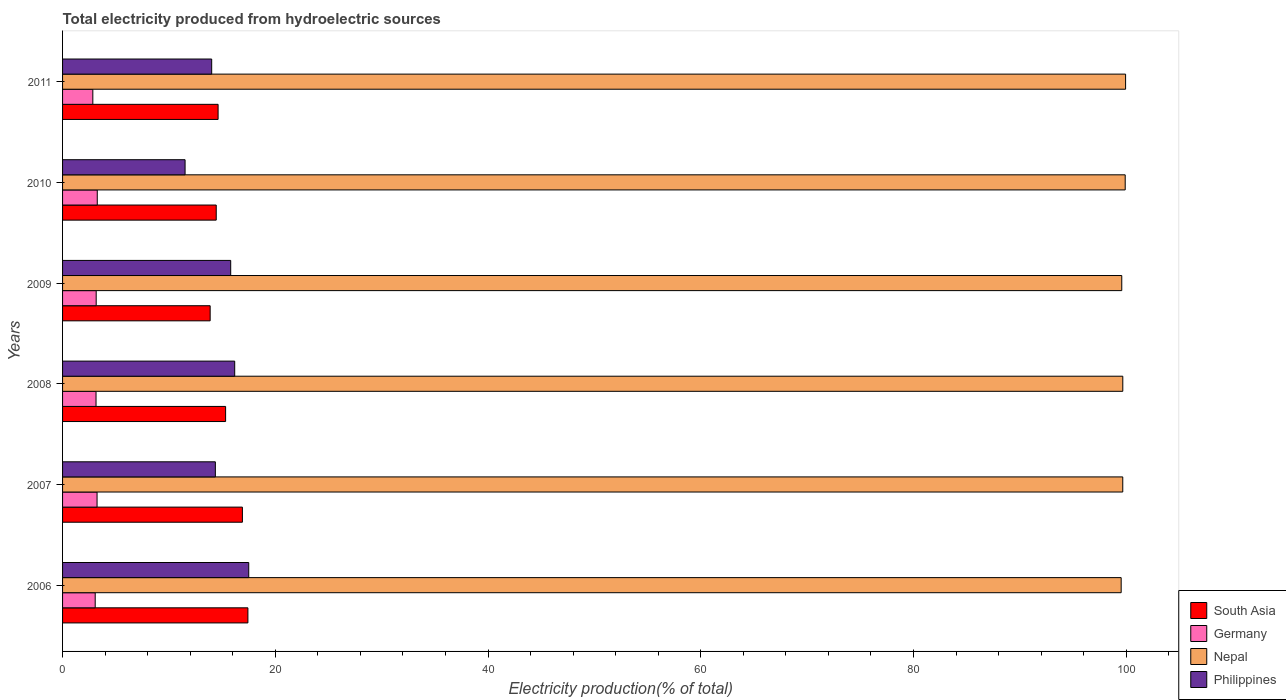Are the number of bars per tick equal to the number of legend labels?
Provide a succinct answer. Yes. What is the label of the 5th group of bars from the top?
Keep it short and to the point. 2007. In how many cases, is the number of bars for a given year not equal to the number of legend labels?
Give a very brief answer. 0. What is the total electricity produced in South Asia in 2006?
Ensure brevity in your answer.  17.43. Across all years, what is the maximum total electricity produced in Germany?
Provide a succinct answer. 3.26. Across all years, what is the minimum total electricity produced in Nepal?
Offer a terse response. 99.53. In which year was the total electricity produced in South Asia maximum?
Ensure brevity in your answer.  2006. In which year was the total electricity produced in South Asia minimum?
Provide a succinct answer. 2009. What is the total total electricity produced in South Asia in the graph?
Ensure brevity in your answer.  92.61. What is the difference between the total electricity produced in Nepal in 2007 and that in 2011?
Offer a terse response. -0.27. What is the difference between the total electricity produced in South Asia in 2011 and the total electricity produced in Nepal in 2007?
Keep it short and to the point. -85.05. What is the average total electricity produced in Germany per year?
Your response must be concise. 3.12. In the year 2006, what is the difference between the total electricity produced in Nepal and total electricity produced in South Asia?
Your answer should be very brief. 82.1. What is the ratio of the total electricity produced in Philippines in 2008 to that in 2011?
Keep it short and to the point. 1.15. Is the total electricity produced in Philippines in 2006 less than that in 2008?
Ensure brevity in your answer.  No. Is the difference between the total electricity produced in Nepal in 2006 and 2010 greater than the difference between the total electricity produced in South Asia in 2006 and 2010?
Your answer should be very brief. No. What is the difference between the highest and the second highest total electricity produced in Philippines?
Offer a very short reply. 1.32. What is the difference between the highest and the lowest total electricity produced in South Asia?
Your answer should be compact. 3.55. In how many years, is the total electricity produced in South Asia greater than the average total electricity produced in South Asia taken over all years?
Offer a terse response. 2. Is the sum of the total electricity produced in Philippines in 2006 and 2008 greater than the maximum total electricity produced in Nepal across all years?
Make the answer very short. No. What does the 3rd bar from the top in 2008 represents?
Make the answer very short. Germany. What does the 1st bar from the bottom in 2010 represents?
Make the answer very short. South Asia. How many bars are there?
Your response must be concise. 24. How many years are there in the graph?
Provide a succinct answer. 6. Does the graph contain any zero values?
Offer a terse response. No. Does the graph contain grids?
Your answer should be compact. No. How many legend labels are there?
Your answer should be compact. 4. How are the legend labels stacked?
Keep it short and to the point. Vertical. What is the title of the graph?
Provide a short and direct response. Total electricity produced from hydroelectric sources. What is the Electricity production(% of total) in South Asia in 2006?
Give a very brief answer. 17.43. What is the Electricity production(% of total) of Germany in 2006?
Offer a very short reply. 3.07. What is the Electricity production(% of total) of Nepal in 2006?
Give a very brief answer. 99.53. What is the Electricity production(% of total) of Philippines in 2006?
Give a very brief answer. 17.5. What is the Electricity production(% of total) in South Asia in 2007?
Offer a very short reply. 16.91. What is the Electricity production(% of total) of Germany in 2007?
Provide a short and direct response. 3.24. What is the Electricity production(% of total) in Nepal in 2007?
Provide a short and direct response. 99.68. What is the Electricity production(% of total) in Philippines in 2007?
Offer a terse response. 14.36. What is the Electricity production(% of total) of South Asia in 2008?
Offer a terse response. 15.33. What is the Electricity production(% of total) in Germany in 2008?
Your answer should be very brief. 3.15. What is the Electricity production(% of total) in Nepal in 2008?
Your answer should be compact. 99.68. What is the Electricity production(% of total) in Philippines in 2008?
Provide a short and direct response. 16.18. What is the Electricity production(% of total) in South Asia in 2009?
Give a very brief answer. 13.88. What is the Electricity production(% of total) in Germany in 2009?
Ensure brevity in your answer.  3.16. What is the Electricity production(% of total) of Nepal in 2009?
Give a very brief answer. 99.58. What is the Electricity production(% of total) in Philippines in 2009?
Offer a terse response. 15.81. What is the Electricity production(% of total) in South Asia in 2010?
Give a very brief answer. 14.45. What is the Electricity production(% of total) in Germany in 2010?
Make the answer very short. 3.26. What is the Electricity production(% of total) in Nepal in 2010?
Provide a short and direct response. 99.91. What is the Electricity production(% of total) of Philippines in 2010?
Your response must be concise. 11.52. What is the Electricity production(% of total) in South Asia in 2011?
Ensure brevity in your answer.  14.62. What is the Electricity production(% of total) of Germany in 2011?
Your answer should be compact. 2.85. What is the Electricity production(% of total) in Nepal in 2011?
Offer a very short reply. 99.94. What is the Electricity production(% of total) of Philippines in 2011?
Your answer should be very brief. 14.02. Across all years, what is the maximum Electricity production(% of total) of South Asia?
Your answer should be very brief. 17.43. Across all years, what is the maximum Electricity production(% of total) of Germany?
Provide a short and direct response. 3.26. Across all years, what is the maximum Electricity production(% of total) in Nepal?
Make the answer very short. 99.94. Across all years, what is the maximum Electricity production(% of total) in Philippines?
Offer a very short reply. 17.5. Across all years, what is the minimum Electricity production(% of total) in South Asia?
Provide a short and direct response. 13.88. Across all years, what is the minimum Electricity production(% of total) of Germany?
Ensure brevity in your answer.  2.85. Across all years, what is the minimum Electricity production(% of total) in Nepal?
Provide a succinct answer. 99.53. Across all years, what is the minimum Electricity production(% of total) in Philippines?
Ensure brevity in your answer.  11.52. What is the total Electricity production(% of total) in South Asia in the graph?
Your response must be concise. 92.61. What is the total Electricity production(% of total) of Germany in the graph?
Offer a terse response. 18.73. What is the total Electricity production(% of total) in Nepal in the graph?
Your answer should be compact. 598.32. What is the total Electricity production(% of total) in Philippines in the graph?
Keep it short and to the point. 89.4. What is the difference between the Electricity production(% of total) of South Asia in 2006 and that in 2007?
Provide a succinct answer. 0.52. What is the difference between the Electricity production(% of total) of Germany in 2006 and that in 2007?
Ensure brevity in your answer.  -0.17. What is the difference between the Electricity production(% of total) of Nepal in 2006 and that in 2007?
Your answer should be very brief. -0.15. What is the difference between the Electricity production(% of total) of Philippines in 2006 and that in 2007?
Offer a terse response. 3.14. What is the difference between the Electricity production(% of total) in South Asia in 2006 and that in 2008?
Offer a terse response. 2.1. What is the difference between the Electricity production(% of total) of Germany in 2006 and that in 2008?
Your response must be concise. -0.08. What is the difference between the Electricity production(% of total) of Nepal in 2006 and that in 2008?
Give a very brief answer. -0.15. What is the difference between the Electricity production(% of total) in Philippines in 2006 and that in 2008?
Your answer should be very brief. 1.32. What is the difference between the Electricity production(% of total) of South Asia in 2006 and that in 2009?
Give a very brief answer. 3.55. What is the difference between the Electricity production(% of total) in Germany in 2006 and that in 2009?
Provide a succinct answer. -0.09. What is the difference between the Electricity production(% of total) of Nepal in 2006 and that in 2009?
Provide a short and direct response. -0.06. What is the difference between the Electricity production(% of total) of Philippines in 2006 and that in 2009?
Provide a succinct answer. 1.7. What is the difference between the Electricity production(% of total) in South Asia in 2006 and that in 2010?
Your answer should be compact. 2.98. What is the difference between the Electricity production(% of total) in Germany in 2006 and that in 2010?
Provide a succinct answer. -0.19. What is the difference between the Electricity production(% of total) in Nepal in 2006 and that in 2010?
Your answer should be very brief. -0.38. What is the difference between the Electricity production(% of total) in Philippines in 2006 and that in 2010?
Provide a short and direct response. 5.98. What is the difference between the Electricity production(% of total) in South Asia in 2006 and that in 2011?
Make the answer very short. 2.8. What is the difference between the Electricity production(% of total) of Germany in 2006 and that in 2011?
Provide a succinct answer. 0.22. What is the difference between the Electricity production(% of total) in Nepal in 2006 and that in 2011?
Offer a terse response. -0.42. What is the difference between the Electricity production(% of total) in Philippines in 2006 and that in 2011?
Offer a terse response. 3.48. What is the difference between the Electricity production(% of total) in South Asia in 2007 and that in 2008?
Offer a terse response. 1.58. What is the difference between the Electricity production(% of total) in Germany in 2007 and that in 2008?
Provide a succinct answer. 0.1. What is the difference between the Electricity production(% of total) in Nepal in 2007 and that in 2008?
Give a very brief answer. -0. What is the difference between the Electricity production(% of total) in Philippines in 2007 and that in 2008?
Your response must be concise. -1.82. What is the difference between the Electricity production(% of total) in South Asia in 2007 and that in 2009?
Ensure brevity in your answer.  3.03. What is the difference between the Electricity production(% of total) in Germany in 2007 and that in 2009?
Give a very brief answer. 0.08. What is the difference between the Electricity production(% of total) in Nepal in 2007 and that in 2009?
Make the answer very short. 0.1. What is the difference between the Electricity production(% of total) in Philippines in 2007 and that in 2009?
Your answer should be very brief. -1.44. What is the difference between the Electricity production(% of total) in South Asia in 2007 and that in 2010?
Ensure brevity in your answer.  2.46. What is the difference between the Electricity production(% of total) in Germany in 2007 and that in 2010?
Give a very brief answer. -0.02. What is the difference between the Electricity production(% of total) in Nepal in 2007 and that in 2010?
Provide a short and direct response. -0.23. What is the difference between the Electricity production(% of total) in Philippines in 2007 and that in 2010?
Provide a short and direct response. 2.85. What is the difference between the Electricity production(% of total) in South Asia in 2007 and that in 2011?
Make the answer very short. 2.28. What is the difference between the Electricity production(% of total) of Germany in 2007 and that in 2011?
Keep it short and to the point. 0.4. What is the difference between the Electricity production(% of total) in Nepal in 2007 and that in 2011?
Ensure brevity in your answer.  -0.27. What is the difference between the Electricity production(% of total) in Philippines in 2007 and that in 2011?
Make the answer very short. 0.35. What is the difference between the Electricity production(% of total) in South Asia in 2008 and that in 2009?
Provide a short and direct response. 1.45. What is the difference between the Electricity production(% of total) of Germany in 2008 and that in 2009?
Give a very brief answer. -0.01. What is the difference between the Electricity production(% of total) in Nepal in 2008 and that in 2009?
Make the answer very short. 0.1. What is the difference between the Electricity production(% of total) in Philippines in 2008 and that in 2009?
Ensure brevity in your answer.  0.38. What is the difference between the Electricity production(% of total) in South Asia in 2008 and that in 2010?
Keep it short and to the point. 0.88. What is the difference between the Electricity production(% of total) in Germany in 2008 and that in 2010?
Ensure brevity in your answer.  -0.12. What is the difference between the Electricity production(% of total) of Nepal in 2008 and that in 2010?
Your response must be concise. -0.23. What is the difference between the Electricity production(% of total) of Philippines in 2008 and that in 2010?
Keep it short and to the point. 4.66. What is the difference between the Electricity production(% of total) in South Asia in 2008 and that in 2011?
Provide a short and direct response. 0.71. What is the difference between the Electricity production(% of total) in Germany in 2008 and that in 2011?
Your answer should be very brief. 0.3. What is the difference between the Electricity production(% of total) of Nepal in 2008 and that in 2011?
Give a very brief answer. -0.26. What is the difference between the Electricity production(% of total) of Philippines in 2008 and that in 2011?
Make the answer very short. 2.16. What is the difference between the Electricity production(% of total) in South Asia in 2009 and that in 2010?
Provide a succinct answer. -0.57. What is the difference between the Electricity production(% of total) of Germany in 2009 and that in 2010?
Offer a terse response. -0.1. What is the difference between the Electricity production(% of total) in Nepal in 2009 and that in 2010?
Keep it short and to the point. -0.32. What is the difference between the Electricity production(% of total) in Philippines in 2009 and that in 2010?
Offer a very short reply. 4.29. What is the difference between the Electricity production(% of total) in South Asia in 2009 and that in 2011?
Make the answer very short. -0.75. What is the difference between the Electricity production(% of total) of Germany in 2009 and that in 2011?
Offer a terse response. 0.32. What is the difference between the Electricity production(% of total) of Nepal in 2009 and that in 2011?
Give a very brief answer. -0.36. What is the difference between the Electricity production(% of total) of Philippines in 2009 and that in 2011?
Offer a very short reply. 1.79. What is the difference between the Electricity production(% of total) of South Asia in 2010 and that in 2011?
Provide a short and direct response. -0.18. What is the difference between the Electricity production(% of total) in Germany in 2010 and that in 2011?
Your response must be concise. 0.42. What is the difference between the Electricity production(% of total) of Nepal in 2010 and that in 2011?
Your response must be concise. -0.04. What is the difference between the Electricity production(% of total) of Philippines in 2010 and that in 2011?
Provide a succinct answer. -2.5. What is the difference between the Electricity production(% of total) in South Asia in 2006 and the Electricity production(% of total) in Germany in 2007?
Ensure brevity in your answer.  14.18. What is the difference between the Electricity production(% of total) of South Asia in 2006 and the Electricity production(% of total) of Nepal in 2007?
Give a very brief answer. -82.25. What is the difference between the Electricity production(% of total) of South Asia in 2006 and the Electricity production(% of total) of Philippines in 2007?
Offer a very short reply. 3.06. What is the difference between the Electricity production(% of total) in Germany in 2006 and the Electricity production(% of total) in Nepal in 2007?
Your answer should be very brief. -96.61. What is the difference between the Electricity production(% of total) of Germany in 2006 and the Electricity production(% of total) of Philippines in 2007?
Your answer should be compact. -11.3. What is the difference between the Electricity production(% of total) of Nepal in 2006 and the Electricity production(% of total) of Philippines in 2007?
Provide a succinct answer. 85.16. What is the difference between the Electricity production(% of total) in South Asia in 2006 and the Electricity production(% of total) in Germany in 2008?
Offer a terse response. 14.28. What is the difference between the Electricity production(% of total) in South Asia in 2006 and the Electricity production(% of total) in Nepal in 2008?
Ensure brevity in your answer.  -82.25. What is the difference between the Electricity production(% of total) in South Asia in 2006 and the Electricity production(% of total) in Philippines in 2008?
Keep it short and to the point. 1.24. What is the difference between the Electricity production(% of total) in Germany in 2006 and the Electricity production(% of total) in Nepal in 2008?
Your response must be concise. -96.61. What is the difference between the Electricity production(% of total) of Germany in 2006 and the Electricity production(% of total) of Philippines in 2008?
Your response must be concise. -13.12. What is the difference between the Electricity production(% of total) in Nepal in 2006 and the Electricity production(% of total) in Philippines in 2008?
Provide a short and direct response. 83.34. What is the difference between the Electricity production(% of total) in South Asia in 2006 and the Electricity production(% of total) in Germany in 2009?
Offer a terse response. 14.26. What is the difference between the Electricity production(% of total) in South Asia in 2006 and the Electricity production(% of total) in Nepal in 2009?
Your answer should be compact. -82.16. What is the difference between the Electricity production(% of total) in South Asia in 2006 and the Electricity production(% of total) in Philippines in 2009?
Give a very brief answer. 1.62. What is the difference between the Electricity production(% of total) of Germany in 2006 and the Electricity production(% of total) of Nepal in 2009?
Provide a short and direct response. -96.51. What is the difference between the Electricity production(% of total) in Germany in 2006 and the Electricity production(% of total) in Philippines in 2009?
Provide a short and direct response. -12.74. What is the difference between the Electricity production(% of total) in Nepal in 2006 and the Electricity production(% of total) in Philippines in 2009?
Provide a short and direct response. 83.72. What is the difference between the Electricity production(% of total) in South Asia in 2006 and the Electricity production(% of total) in Germany in 2010?
Provide a succinct answer. 14.16. What is the difference between the Electricity production(% of total) of South Asia in 2006 and the Electricity production(% of total) of Nepal in 2010?
Provide a short and direct response. -82.48. What is the difference between the Electricity production(% of total) in South Asia in 2006 and the Electricity production(% of total) in Philippines in 2010?
Provide a short and direct response. 5.91. What is the difference between the Electricity production(% of total) of Germany in 2006 and the Electricity production(% of total) of Nepal in 2010?
Your answer should be compact. -96.84. What is the difference between the Electricity production(% of total) of Germany in 2006 and the Electricity production(% of total) of Philippines in 2010?
Offer a terse response. -8.45. What is the difference between the Electricity production(% of total) of Nepal in 2006 and the Electricity production(% of total) of Philippines in 2010?
Ensure brevity in your answer.  88.01. What is the difference between the Electricity production(% of total) of South Asia in 2006 and the Electricity production(% of total) of Germany in 2011?
Your answer should be very brief. 14.58. What is the difference between the Electricity production(% of total) in South Asia in 2006 and the Electricity production(% of total) in Nepal in 2011?
Keep it short and to the point. -82.52. What is the difference between the Electricity production(% of total) of South Asia in 2006 and the Electricity production(% of total) of Philippines in 2011?
Provide a succinct answer. 3.41. What is the difference between the Electricity production(% of total) in Germany in 2006 and the Electricity production(% of total) in Nepal in 2011?
Offer a terse response. -96.87. What is the difference between the Electricity production(% of total) in Germany in 2006 and the Electricity production(% of total) in Philippines in 2011?
Make the answer very short. -10.95. What is the difference between the Electricity production(% of total) of Nepal in 2006 and the Electricity production(% of total) of Philippines in 2011?
Make the answer very short. 85.51. What is the difference between the Electricity production(% of total) of South Asia in 2007 and the Electricity production(% of total) of Germany in 2008?
Keep it short and to the point. 13.76. What is the difference between the Electricity production(% of total) in South Asia in 2007 and the Electricity production(% of total) in Nepal in 2008?
Offer a terse response. -82.77. What is the difference between the Electricity production(% of total) of South Asia in 2007 and the Electricity production(% of total) of Philippines in 2008?
Your answer should be compact. 0.72. What is the difference between the Electricity production(% of total) of Germany in 2007 and the Electricity production(% of total) of Nepal in 2008?
Provide a succinct answer. -96.44. What is the difference between the Electricity production(% of total) of Germany in 2007 and the Electricity production(% of total) of Philippines in 2008?
Provide a short and direct response. -12.94. What is the difference between the Electricity production(% of total) of Nepal in 2007 and the Electricity production(% of total) of Philippines in 2008?
Provide a short and direct response. 83.49. What is the difference between the Electricity production(% of total) of South Asia in 2007 and the Electricity production(% of total) of Germany in 2009?
Provide a succinct answer. 13.75. What is the difference between the Electricity production(% of total) in South Asia in 2007 and the Electricity production(% of total) in Nepal in 2009?
Ensure brevity in your answer.  -82.68. What is the difference between the Electricity production(% of total) of South Asia in 2007 and the Electricity production(% of total) of Philippines in 2009?
Ensure brevity in your answer.  1.1. What is the difference between the Electricity production(% of total) in Germany in 2007 and the Electricity production(% of total) in Nepal in 2009?
Give a very brief answer. -96.34. What is the difference between the Electricity production(% of total) in Germany in 2007 and the Electricity production(% of total) in Philippines in 2009?
Give a very brief answer. -12.56. What is the difference between the Electricity production(% of total) of Nepal in 2007 and the Electricity production(% of total) of Philippines in 2009?
Provide a succinct answer. 83.87. What is the difference between the Electricity production(% of total) in South Asia in 2007 and the Electricity production(% of total) in Germany in 2010?
Make the answer very short. 13.65. What is the difference between the Electricity production(% of total) of South Asia in 2007 and the Electricity production(% of total) of Nepal in 2010?
Offer a terse response. -83. What is the difference between the Electricity production(% of total) in South Asia in 2007 and the Electricity production(% of total) in Philippines in 2010?
Provide a short and direct response. 5.39. What is the difference between the Electricity production(% of total) in Germany in 2007 and the Electricity production(% of total) in Nepal in 2010?
Your response must be concise. -96.66. What is the difference between the Electricity production(% of total) of Germany in 2007 and the Electricity production(% of total) of Philippines in 2010?
Your response must be concise. -8.28. What is the difference between the Electricity production(% of total) of Nepal in 2007 and the Electricity production(% of total) of Philippines in 2010?
Keep it short and to the point. 88.16. What is the difference between the Electricity production(% of total) in South Asia in 2007 and the Electricity production(% of total) in Germany in 2011?
Offer a very short reply. 14.06. What is the difference between the Electricity production(% of total) in South Asia in 2007 and the Electricity production(% of total) in Nepal in 2011?
Provide a succinct answer. -83.04. What is the difference between the Electricity production(% of total) of South Asia in 2007 and the Electricity production(% of total) of Philippines in 2011?
Make the answer very short. 2.89. What is the difference between the Electricity production(% of total) in Germany in 2007 and the Electricity production(% of total) in Nepal in 2011?
Offer a terse response. -96.7. What is the difference between the Electricity production(% of total) of Germany in 2007 and the Electricity production(% of total) of Philippines in 2011?
Your answer should be very brief. -10.78. What is the difference between the Electricity production(% of total) in Nepal in 2007 and the Electricity production(% of total) in Philippines in 2011?
Ensure brevity in your answer.  85.66. What is the difference between the Electricity production(% of total) in South Asia in 2008 and the Electricity production(% of total) in Germany in 2009?
Your answer should be compact. 12.17. What is the difference between the Electricity production(% of total) in South Asia in 2008 and the Electricity production(% of total) in Nepal in 2009?
Your answer should be compact. -84.25. What is the difference between the Electricity production(% of total) in South Asia in 2008 and the Electricity production(% of total) in Philippines in 2009?
Give a very brief answer. -0.48. What is the difference between the Electricity production(% of total) in Germany in 2008 and the Electricity production(% of total) in Nepal in 2009?
Offer a terse response. -96.44. What is the difference between the Electricity production(% of total) in Germany in 2008 and the Electricity production(% of total) in Philippines in 2009?
Keep it short and to the point. -12.66. What is the difference between the Electricity production(% of total) in Nepal in 2008 and the Electricity production(% of total) in Philippines in 2009?
Your response must be concise. 83.87. What is the difference between the Electricity production(% of total) in South Asia in 2008 and the Electricity production(% of total) in Germany in 2010?
Your response must be concise. 12.07. What is the difference between the Electricity production(% of total) in South Asia in 2008 and the Electricity production(% of total) in Nepal in 2010?
Give a very brief answer. -84.58. What is the difference between the Electricity production(% of total) in South Asia in 2008 and the Electricity production(% of total) in Philippines in 2010?
Make the answer very short. 3.81. What is the difference between the Electricity production(% of total) in Germany in 2008 and the Electricity production(% of total) in Nepal in 2010?
Your answer should be very brief. -96.76. What is the difference between the Electricity production(% of total) of Germany in 2008 and the Electricity production(% of total) of Philippines in 2010?
Provide a succinct answer. -8.37. What is the difference between the Electricity production(% of total) in Nepal in 2008 and the Electricity production(% of total) in Philippines in 2010?
Give a very brief answer. 88.16. What is the difference between the Electricity production(% of total) in South Asia in 2008 and the Electricity production(% of total) in Germany in 2011?
Provide a short and direct response. 12.48. What is the difference between the Electricity production(% of total) in South Asia in 2008 and the Electricity production(% of total) in Nepal in 2011?
Ensure brevity in your answer.  -84.61. What is the difference between the Electricity production(% of total) in South Asia in 2008 and the Electricity production(% of total) in Philippines in 2011?
Offer a terse response. 1.31. What is the difference between the Electricity production(% of total) in Germany in 2008 and the Electricity production(% of total) in Nepal in 2011?
Offer a terse response. -96.8. What is the difference between the Electricity production(% of total) in Germany in 2008 and the Electricity production(% of total) in Philippines in 2011?
Your response must be concise. -10.87. What is the difference between the Electricity production(% of total) in Nepal in 2008 and the Electricity production(% of total) in Philippines in 2011?
Offer a very short reply. 85.66. What is the difference between the Electricity production(% of total) in South Asia in 2009 and the Electricity production(% of total) in Germany in 2010?
Make the answer very short. 10.61. What is the difference between the Electricity production(% of total) in South Asia in 2009 and the Electricity production(% of total) in Nepal in 2010?
Keep it short and to the point. -86.03. What is the difference between the Electricity production(% of total) of South Asia in 2009 and the Electricity production(% of total) of Philippines in 2010?
Give a very brief answer. 2.36. What is the difference between the Electricity production(% of total) of Germany in 2009 and the Electricity production(% of total) of Nepal in 2010?
Offer a very short reply. -96.75. What is the difference between the Electricity production(% of total) of Germany in 2009 and the Electricity production(% of total) of Philippines in 2010?
Your answer should be very brief. -8.36. What is the difference between the Electricity production(% of total) of Nepal in 2009 and the Electricity production(% of total) of Philippines in 2010?
Keep it short and to the point. 88.06. What is the difference between the Electricity production(% of total) in South Asia in 2009 and the Electricity production(% of total) in Germany in 2011?
Provide a succinct answer. 11.03. What is the difference between the Electricity production(% of total) in South Asia in 2009 and the Electricity production(% of total) in Nepal in 2011?
Your response must be concise. -86.07. What is the difference between the Electricity production(% of total) in South Asia in 2009 and the Electricity production(% of total) in Philippines in 2011?
Your answer should be very brief. -0.14. What is the difference between the Electricity production(% of total) in Germany in 2009 and the Electricity production(% of total) in Nepal in 2011?
Give a very brief answer. -96.78. What is the difference between the Electricity production(% of total) of Germany in 2009 and the Electricity production(% of total) of Philippines in 2011?
Your response must be concise. -10.86. What is the difference between the Electricity production(% of total) of Nepal in 2009 and the Electricity production(% of total) of Philippines in 2011?
Provide a short and direct response. 85.56. What is the difference between the Electricity production(% of total) of South Asia in 2010 and the Electricity production(% of total) of Germany in 2011?
Offer a very short reply. 11.6. What is the difference between the Electricity production(% of total) in South Asia in 2010 and the Electricity production(% of total) in Nepal in 2011?
Give a very brief answer. -85.5. What is the difference between the Electricity production(% of total) of South Asia in 2010 and the Electricity production(% of total) of Philippines in 2011?
Provide a short and direct response. 0.43. What is the difference between the Electricity production(% of total) of Germany in 2010 and the Electricity production(% of total) of Nepal in 2011?
Give a very brief answer. -96.68. What is the difference between the Electricity production(% of total) of Germany in 2010 and the Electricity production(% of total) of Philippines in 2011?
Your response must be concise. -10.76. What is the difference between the Electricity production(% of total) in Nepal in 2010 and the Electricity production(% of total) in Philippines in 2011?
Your response must be concise. 85.89. What is the average Electricity production(% of total) of South Asia per year?
Your response must be concise. 15.43. What is the average Electricity production(% of total) in Germany per year?
Ensure brevity in your answer.  3.12. What is the average Electricity production(% of total) of Nepal per year?
Your answer should be compact. 99.72. What is the average Electricity production(% of total) of Philippines per year?
Provide a short and direct response. 14.9. In the year 2006, what is the difference between the Electricity production(% of total) in South Asia and Electricity production(% of total) in Germany?
Provide a succinct answer. 14.36. In the year 2006, what is the difference between the Electricity production(% of total) of South Asia and Electricity production(% of total) of Nepal?
Your answer should be compact. -82.1. In the year 2006, what is the difference between the Electricity production(% of total) in South Asia and Electricity production(% of total) in Philippines?
Make the answer very short. -0.08. In the year 2006, what is the difference between the Electricity production(% of total) in Germany and Electricity production(% of total) in Nepal?
Offer a terse response. -96.46. In the year 2006, what is the difference between the Electricity production(% of total) in Germany and Electricity production(% of total) in Philippines?
Ensure brevity in your answer.  -14.44. In the year 2006, what is the difference between the Electricity production(% of total) in Nepal and Electricity production(% of total) in Philippines?
Your response must be concise. 82.02. In the year 2007, what is the difference between the Electricity production(% of total) of South Asia and Electricity production(% of total) of Germany?
Your answer should be compact. 13.66. In the year 2007, what is the difference between the Electricity production(% of total) of South Asia and Electricity production(% of total) of Nepal?
Keep it short and to the point. -82.77. In the year 2007, what is the difference between the Electricity production(% of total) in South Asia and Electricity production(% of total) in Philippines?
Ensure brevity in your answer.  2.54. In the year 2007, what is the difference between the Electricity production(% of total) in Germany and Electricity production(% of total) in Nepal?
Offer a very short reply. -96.43. In the year 2007, what is the difference between the Electricity production(% of total) of Germany and Electricity production(% of total) of Philippines?
Give a very brief answer. -11.12. In the year 2007, what is the difference between the Electricity production(% of total) in Nepal and Electricity production(% of total) in Philippines?
Offer a terse response. 85.31. In the year 2008, what is the difference between the Electricity production(% of total) in South Asia and Electricity production(% of total) in Germany?
Make the answer very short. 12.18. In the year 2008, what is the difference between the Electricity production(% of total) of South Asia and Electricity production(% of total) of Nepal?
Keep it short and to the point. -84.35. In the year 2008, what is the difference between the Electricity production(% of total) in South Asia and Electricity production(% of total) in Philippines?
Keep it short and to the point. -0.85. In the year 2008, what is the difference between the Electricity production(% of total) of Germany and Electricity production(% of total) of Nepal?
Your response must be concise. -96.53. In the year 2008, what is the difference between the Electricity production(% of total) in Germany and Electricity production(% of total) in Philippines?
Your answer should be very brief. -13.04. In the year 2008, what is the difference between the Electricity production(% of total) in Nepal and Electricity production(% of total) in Philippines?
Provide a short and direct response. 83.5. In the year 2009, what is the difference between the Electricity production(% of total) in South Asia and Electricity production(% of total) in Germany?
Ensure brevity in your answer.  10.72. In the year 2009, what is the difference between the Electricity production(% of total) in South Asia and Electricity production(% of total) in Nepal?
Offer a very short reply. -85.71. In the year 2009, what is the difference between the Electricity production(% of total) of South Asia and Electricity production(% of total) of Philippines?
Your answer should be compact. -1.93. In the year 2009, what is the difference between the Electricity production(% of total) in Germany and Electricity production(% of total) in Nepal?
Offer a terse response. -96.42. In the year 2009, what is the difference between the Electricity production(% of total) of Germany and Electricity production(% of total) of Philippines?
Your answer should be very brief. -12.65. In the year 2009, what is the difference between the Electricity production(% of total) of Nepal and Electricity production(% of total) of Philippines?
Provide a succinct answer. 83.78. In the year 2010, what is the difference between the Electricity production(% of total) in South Asia and Electricity production(% of total) in Germany?
Offer a terse response. 11.19. In the year 2010, what is the difference between the Electricity production(% of total) in South Asia and Electricity production(% of total) in Nepal?
Offer a very short reply. -85.46. In the year 2010, what is the difference between the Electricity production(% of total) of South Asia and Electricity production(% of total) of Philippines?
Your response must be concise. 2.93. In the year 2010, what is the difference between the Electricity production(% of total) of Germany and Electricity production(% of total) of Nepal?
Give a very brief answer. -96.64. In the year 2010, what is the difference between the Electricity production(% of total) of Germany and Electricity production(% of total) of Philippines?
Ensure brevity in your answer.  -8.26. In the year 2010, what is the difference between the Electricity production(% of total) of Nepal and Electricity production(% of total) of Philippines?
Provide a succinct answer. 88.39. In the year 2011, what is the difference between the Electricity production(% of total) in South Asia and Electricity production(% of total) in Germany?
Keep it short and to the point. 11.78. In the year 2011, what is the difference between the Electricity production(% of total) in South Asia and Electricity production(% of total) in Nepal?
Offer a very short reply. -85.32. In the year 2011, what is the difference between the Electricity production(% of total) in South Asia and Electricity production(% of total) in Philippines?
Offer a very short reply. 0.6. In the year 2011, what is the difference between the Electricity production(% of total) of Germany and Electricity production(% of total) of Nepal?
Your answer should be compact. -97.1. In the year 2011, what is the difference between the Electricity production(% of total) of Germany and Electricity production(% of total) of Philippines?
Keep it short and to the point. -11.17. In the year 2011, what is the difference between the Electricity production(% of total) in Nepal and Electricity production(% of total) in Philippines?
Provide a succinct answer. 85.92. What is the ratio of the Electricity production(% of total) of South Asia in 2006 to that in 2007?
Give a very brief answer. 1.03. What is the ratio of the Electricity production(% of total) of Germany in 2006 to that in 2007?
Your response must be concise. 0.95. What is the ratio of the Electricity production(% of total) in Philippines in 2006 to that in 2007?
Give a very brief answer. 1.22. What is the ratio of the Electricity production(% of total) of South Asia in 2006 to that in 2008?
Offer a terse response. 1.14. What is the ratio of the Electricity production(% of total) of Germany in 2006 to that in 2008?
Your answer should be very brief. 0.97. What is the ratio of the Electricity production(% of total) in Philippines in 2006 to that in 2008?
Offer a terse response. 1.08. What is the ratio of the Electricity production(% of total) of South Asia in 2006 to that in 2009?
Give a very brief answer. 1.26. What is the ratio of the Electricity production(% of total) in Germany in 2006 to that in 2009?
Ensure brevity in your answer.  0.97. What is the ratio of the Electricity production(% of total) in Nepal in 2006 to that in 2009?
Give a very brief answer. 1. What is the ratio of the Electricity production(% of total) of Philippines in 2006 to that in 2009?
Provide a short and direct response. 1.11. What is the ratio of the Electricity production(% of total) in South Asia in 2006 to that in 2010?
Give a very brief answer. 1.21. What is the ratio of the Electricity production(% of total) in Germany in 2006 to that in 2010?
Provide a short and direct response. 0.94. What is the ratio of the Electricity production(% of total) of Philippines in 2006 to that in 2010?
Your response must be concise. 1.52. What is the ratio of the Electricity production(% of total) of South Asia in 2006 to that in 2011?
Your answer should be very brief. 1.19. What is the ratio of the Electricity production(% of total) in Germany in 2006 to that in 2011?
Provide a short and direct response. 1.08. What is the ratio of the Electricity production(% of total) in Philippines in 2006 to that in 2011?
Your response must be concise. 1.25. What is the ratio of the Electricity production(% of total) in South Asia in 2007 to that in 2008?
Offer a terse response. 1.1. What is the ratio of the Electricity production(% of total) of Germany in 2007 to that in 2008?
Give a very brief answer. 1.03. What is the ratio of the Electricity production(% of total) in Nepal in 2007 to that in 2008?
Provide a short and direct response. 1. What is the ratio of the Electricity production(% of total) in Philippines in 2007 to that in 2008?
Your answer should be very brief. 0.89. What is the ratio of the Electricity production(% of total) of South Asia in 2007 to that in 2009?
Your answer should be very brief. 1.22. What is the ratio of the Electricity production(% of total) in Germany in 2007 to that in 2009?
Ensure brevity in your answer.  1.03. What is the ratio of the Electricity production(% of total) in Philippines in 2007 to that in 2009?
Your answer should be very brief. 0.91. What is the ratio of the Electricity production(% of total) of South Asia in 2007 to that in 2010?
Provide a succinct answer. 1.17. What is the ratio of the Electricity production(% of total) in Germany in 2007 to that in 2010?
Offer a very short reply. 0.99. What is the ratio of the Electricity production(% of total) in Philippines in 2007 to that in 2010?
Make the answer very short. 1.25. What is the ratio of the Electricity production(% of total) of South Asia in 2007 to that in 2011?
Provide a short and direct response. 1.16. What is the ratio of the Electricity production(% of total) of Germany in 2007 to that in 2011?
Make the answer very short. 1.14. What is the ratio of the Electricity production(% of total) in Philippines in 2007 to that in 2011?
Your answer should be compact. 1.02. What is the ratio of the Electricity production(% of total) in South Asia in 2008 to that in 2009?
Your response must be concise. 1.1. What is the ratio of the Electricity production(% of total) of Germany in 2008 to that in 2009?
Offer a very short reply. 1. What is the ratio of the Electricity production(% of total) in Nepal in 2008 to that in 2009?
Provide a succinct answer. 1. What is the ratio of the Electricity production(% of total) in Philippines in 2008 to that in 2009?
Give a very brief answer. 1.02. What is the ratio of the Electricity production(% of total) in South Asia in 2008 to that in 2010?
Offer a terse response. 1.06. What is the ratio of the Electricity production(% of total) in Germany in 2008 to that in 2010?
Offer a very short reply. 0.96. What is the ratio of the Electricity production(% of total) of Philippines in 2008 to that in 2010?
Offer a very short reply. 1.41. What is the ratio of the Electricity production(% of total) of South Asia in 2008 to that in 2011?
Give a very brief answer. 1.05. What is the ratio of the Electricity production(% of total) of Germany in 2008 to that in 2011?
Give a very brief answer. 1.11. What is the ratio of the Electricity production(% of total) in Nepal in 2008 to that in 2011?
Your answer should be compact. 1. What is the ratio of the Electricity production(% of total) in Philippines in 2008 to that in 2011?
Provide a succinct answer. 1.15. What is the ratio of the Electricity production(% of total) of South Asia in 2009 to that in 2010?
Make the answer very short. 0.96. What is the ratio of the Electricity production(% of total) in Germany in 2009 to that in 2010?
Your response must be concise. 0.97. What is the ratio of the Electricity production(% of total) of Philippines in 2009 to that in 2010?
Ensure brevity in your answer.  1.37. What is the ratio of the Electricity production(% of total) in South Asia in 2009 to that in 2011?
Ensure brevity in your answer.  0.95. What is the ratio of the Electricity production(% of total) of Germany in 2009 to that in 2011?
Ensure brevity in your answer.  1.11. What is the ratio of the Electricity production(% of total) of Philippines in 2009 to that in 2011?
Provide a succinct answer. 1.13. What is the ratio of the Electricity production(% of total) of South Asia in 2010 to that in 2011?
Your response must be concise. 0.99. What is the ratio of the Electricity production(% of total) of Germany in 2010 to that in 2011?
Your answer should be compact. 1.15. What is the ratio of the Electricity production(% of total) in Philippines in 2010 to that in 2011?
Keep it short and to the point. 0.82. What is the difference between the highest and the second highest Electricity production(% of total) in South Asia?
Your answer should be compact. 0.52. What is the difference between the highest and the second highest Electricity production(% of total) in Germany?
Offer a very short reply. 0.02. What is the difference between the highest and the second highest Electricity production(% of total) in Nepal?
Provide a succinct answer. 0.04. What is the difference between the highest and the second highest Electricity production(% of total) in Philippines?
Make the answer very short. 1.32. What is the difference between the highest and the lowest Electricity production(% of total) in South Asia?
Provide a short and direct response. 3.55. What is the difference between the highest and the lowest Electricity production(% of total) of Germany?
Offer a terse response. 0.42. What is the difference between the highest and the lowest Electricity production(% of total) in Nepal?
Ensure brevity in your answer.  0.42. What is the difference between the highest and the lowest Electricity production(% of total) of Philippines?
Your answer should be very brief. 5.98. 